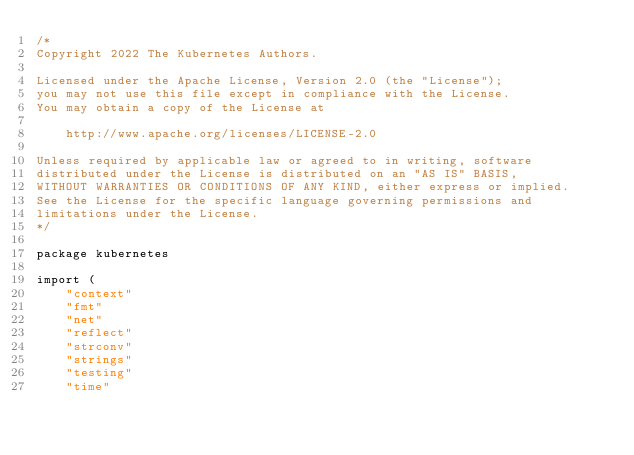<code> <loc_0><loc_0><loc_500><loc_500><_Go_>/*
Copyright 2022 The Kubernetes Authors.

Licensed under the Apache License, Version 2.0 (the "License");
you may not use this file except in compliance with the License.
You may obtain a copy of the License at

    http://www.apache.org/licenses/LICENSE-2.0

Unless required by applicable law or agreed to in writing, software
distributed under the License is distributed on an "AS IS" BASIS,
WITHOUT WARRANTIES OR CONDITIONS OF ANY KIND, either express or implied.
See the License for the specific language governing permissions and
limitations under the License.
*/

package kubernetes

import (
	"context"
	"fmt"
	"net"
	"reflect"
	"strconv"
	"strings"
	"testing"
	"time"
</code> 